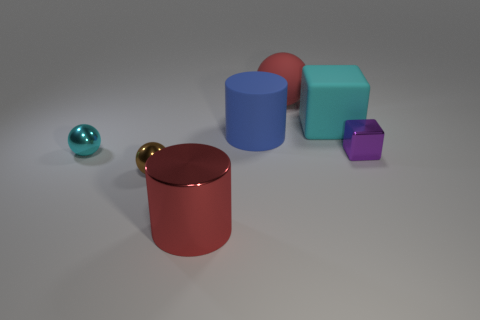What number of big red shiny objects are to the right of the shiny thing in front of the small brown object? 0 